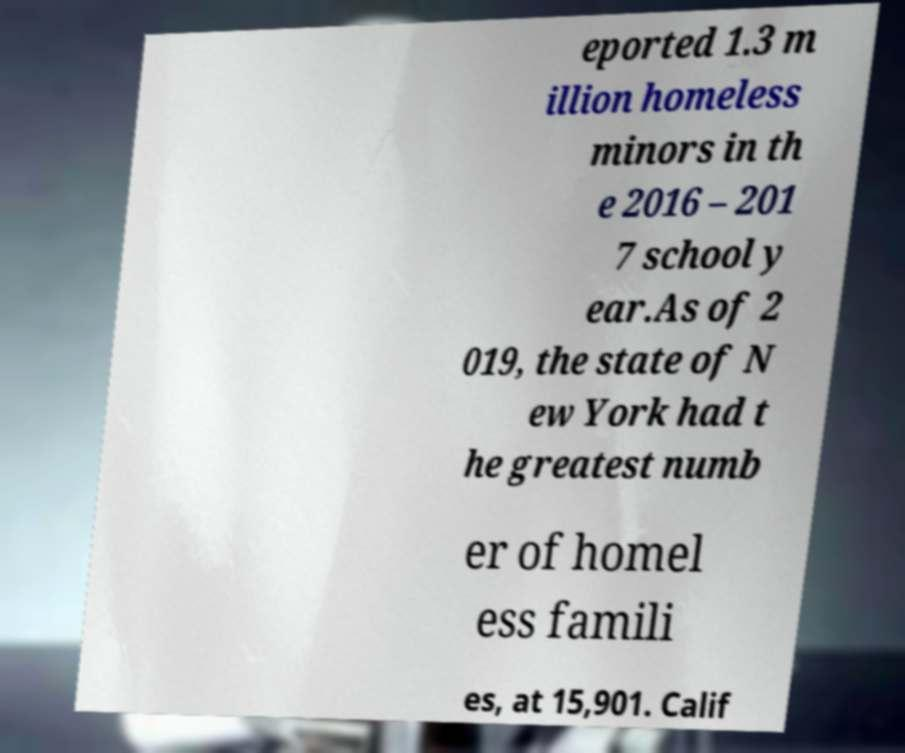Could you extract and type out the text from this image? eported 1.3 m illion homeless minors in th e 2016 – 201 7 school y ear.As of 2 019, the state of N ew York had t he greatest numb er of homel ess famili es, at 15,901. Calif 